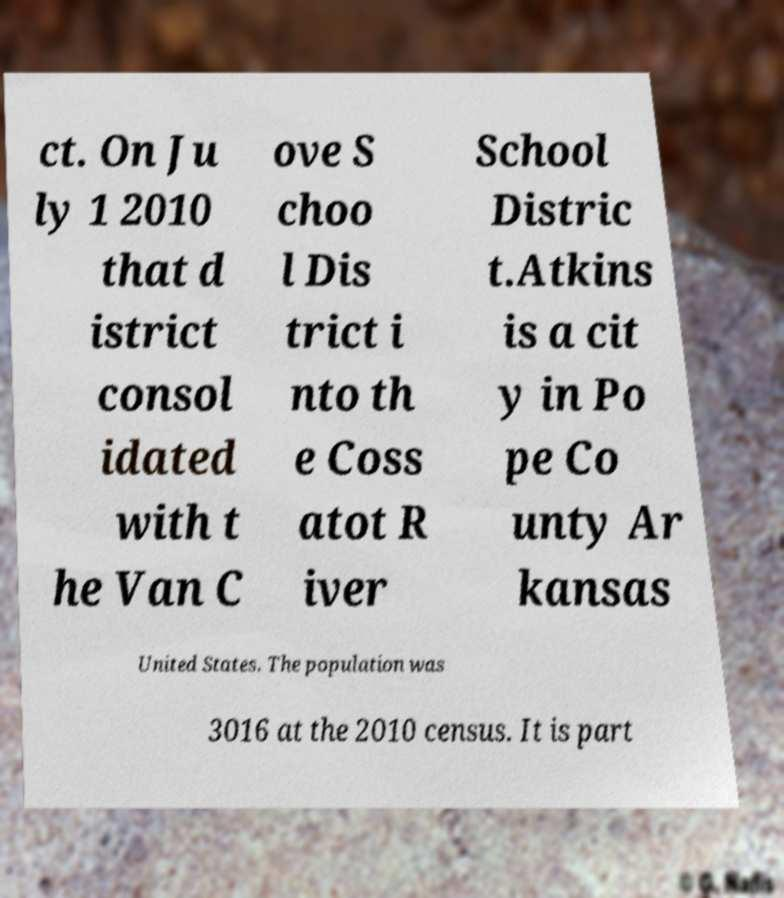Can you accurately transcribe the text from the provided image for me? ct. On Ju ly 1 2010 that d istrict consol idated with t he Van C ove S choo l Dis trict i nto th e Coss atot R iver School Distric t.Atkins is a cit y in Po pe Co unty Ar kansas United States. The population was 3016 at the 2010 census. It is part 